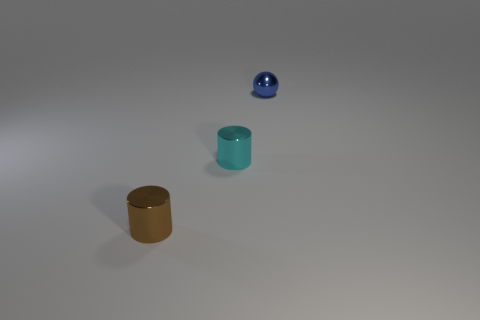How many objects are small cyan rubber things or small blue metallic balls?
Offer a terse response. 1. Are there any brown things of the same shape as the cyan metal object?
Offer a very short reply. Yes. There is a tiny brown shiny cylinder; what number of small cyan objects are to the left of it?
Make the answer very short. 0. The tiny cylinder right of the small cylinder to the left of the cyan metal object is made of what material?
Provide a succinct answer. Metal. Are there any cyan metallic cylinders that have the same size as the blue sphere?
Give a very brief answer. Yes. There is a object that is in front of the small cyan cylinder; what is its color?
Keep it short and to the point. Brown. Is there a tiny cyan metal cylinder behind the cylinder to the right of the small brown cylinder?
Offer a very short reply. No. There is a cylinder that is right of the brown metallic thing; does it have the same size as the object in front of the cyan cylinder?
Make the answer very short. Yes. What is the size of the metal cylinder to the right of the cylinder that is on the left side of the small cyan metallic thing?
Ensure brevity in your answer.  Small. What color is the small ball?
Keep it short and to the point. Blue. 